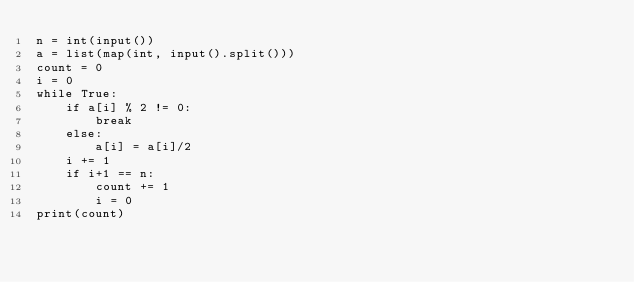<code> <loc_0><loc_0><loc_500><loc_500><_Python_>n = int(input())
a = list(map(int, input().split()))
count = 0
i = 0
while True:
    if a[i] % 2 != 0:
        break
    else:
        a[i] = a[i]/2
    i += 1
    if i+1 == n:
        count += 1
        i = 0
print(count)</code> 